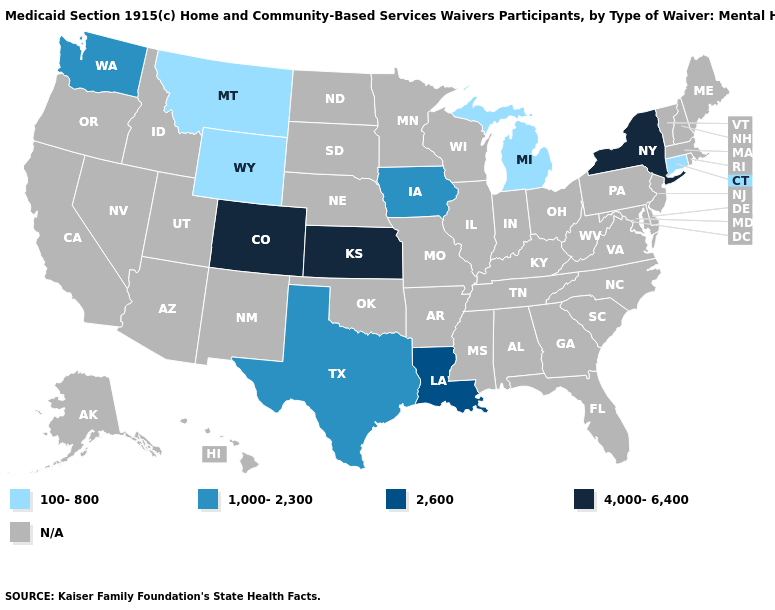How many symbols are there in the legend?
Give a very brief answer. 5. What is the lowest value in the USA?
Quick response, please. 100-800. What is the value of Louisiana?
Short answer required. 2,600. What is the highest value in states that border Minnesota?
Write a very short answer. 1,000-2,300. What is the value of Iowa?
Keep it brief. 1,000-2,300. Name the states that have a value in the range 100-800?
Write a very short answer. Connecticut, Michigan, Montana, Wyoming. Does New York have the highest value in the USA?
Short answer required. Yes. Among the states that border Montana , which have the highest value?
Keep it brief. Wyoming. Among the states that border Oklahoma , which have the highest value?
Quick response, please. Colorado, Kansas. What is the value of New Jersey?
Concise answer only. N/A. Is the legend a continuous bar?
Keep it brief. No. Name the states that have a value in the range 2,600?
Quick response, please. Louisiana. 